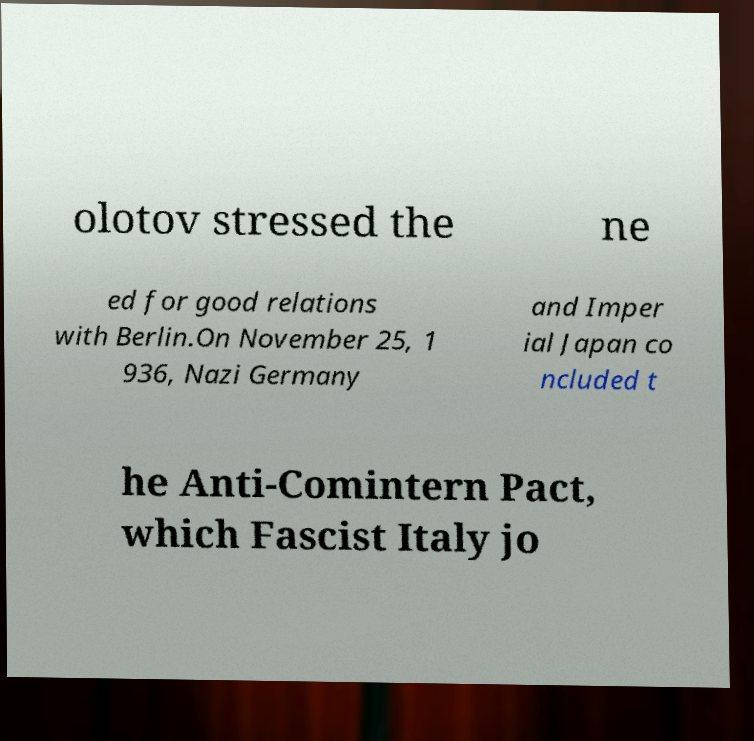I need the written content from this picture converted into text. Can you do that? olotov stressed the ne ed for good relations with Berlin.On November 25, 1 936, Nazi Germany and Imper ial Japan co ncluded t he Anti-Comintern Pact, which Fascist Italy jo 